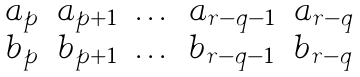<formula> <loc_0><loc_0><loc_500><loc_500>\begin{matrix} a _ { p } & a _ { p + 1 } & \dots & a _ { r - q - 1 } & a _ { r - q } \\ b _ { p } & b _ { p + 1 } & \dots & b _ { r - q - 1 } & b _ { r - q } \end{matrix}</formula> 